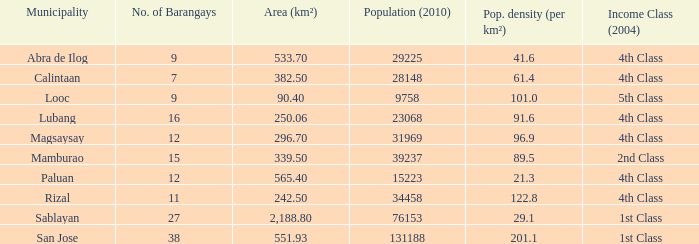In 2010, what was the lowest population? 9758.0. Help me parse the entirety of this table. {'header': ['Municipality', 'No. of Barangays', 'Area (km²)', 'Population (2010)', 'Pop. density (per km²)', 'Income Class (2004)'], 'rows': [['Abra de Ilog', '9', '533.70', '29225', '41.6', '4th Class'], ['Calintaan', '7', '382.50', '28148', '61.4', '4th Class'], ['Looc', '9', '90.40', '9758', '101.0', '5th Class'], ['Lubang', '16', '250.06', '23068', '91.6', '4th Class'], ['Magsaysay', '12', '296.70', '31969', '96.9', '4th Class'], ['Mamburao', '15', '339.50', '39237', '89.5', '2nd Class'], ['Paluan', '12', '565.40', '15223', '21.3', '4th Class'], ['Rizal', '11', '242.50', '34458', '122.8', '4th Class'], ['Sablayan', '27', '2,188.80', '76153', '29.1', '1st Class'], ['San Jose', '38', '551.93', '131188', '201.1', '1st Class']]} 